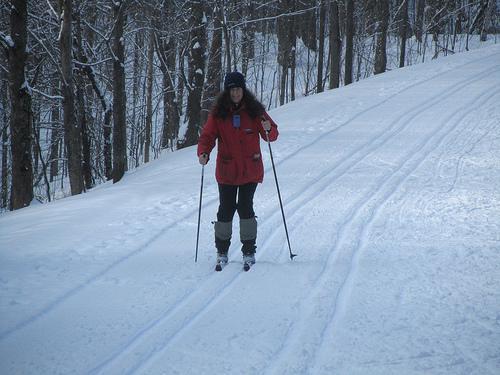How many people are in the picture?
Give a very brief answer. 1. 